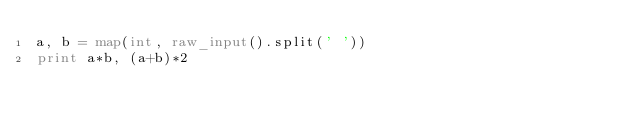Convert code to text. <code><loc_0><loc_0><loc_500><loc_500><_Python_>a, b = map(int, raw_input().split(' '))
print a*b, (a+b)*2</code> 